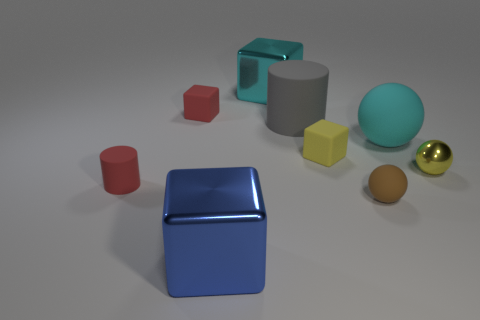Subtract all blocks. How many objects are left? 5 Subtract 3 cubes. How many cubes are left? 1 Subtract all green cylinders. Subtract all yellow spheres. How many cylinders are left? 2 Subtract all green cylinders. How many blue cubes are left? 1 Subtract all large rubber cylinders. Subtract all big matte spheres. How many objects are left? 7 Add 8 small brown balls. How many small brown balls are left? 9 Add 2 red cylinders. How many red cylinders exist? 3 Add 1 large cyan matte balls. How many objects exist? 10 Subtract all cyan balls. How many balls are left? 2 Subtract all big cyan balls. How many balls are left? 2 